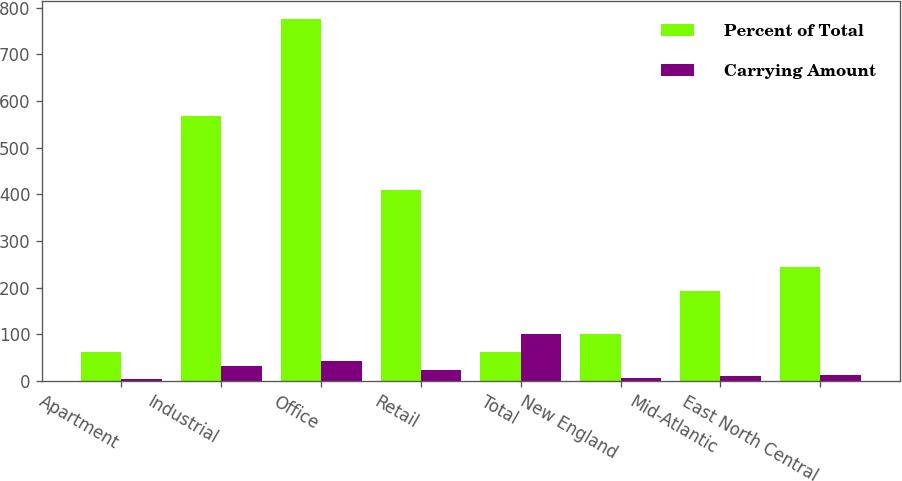<chart> <loc_0><loc_0><loc_500><loc_500><stacked_bar_chart><ecel><fcel>Apartment<fcel>Industrial<fcel>Office<fcel>Retail<fcel>Total<fcel>New England<fcel>Mid-Atlantic<fcel>East North Central<nl><fcel>Percent of Total<fcel>61.1<fcel>567.8<fcel>776.5<fcel>409.7<fcel>61.1<fcel>100.9<fcel>191.5<fcel>244.3<nl><fcel>Carrying Amount<fcel>3.3<fcel>31.3<fcel>42.8<fcel>22.6<fcel>100<fcel>5.6<fcel>10.5<fcel>13.5<nl></chart> 